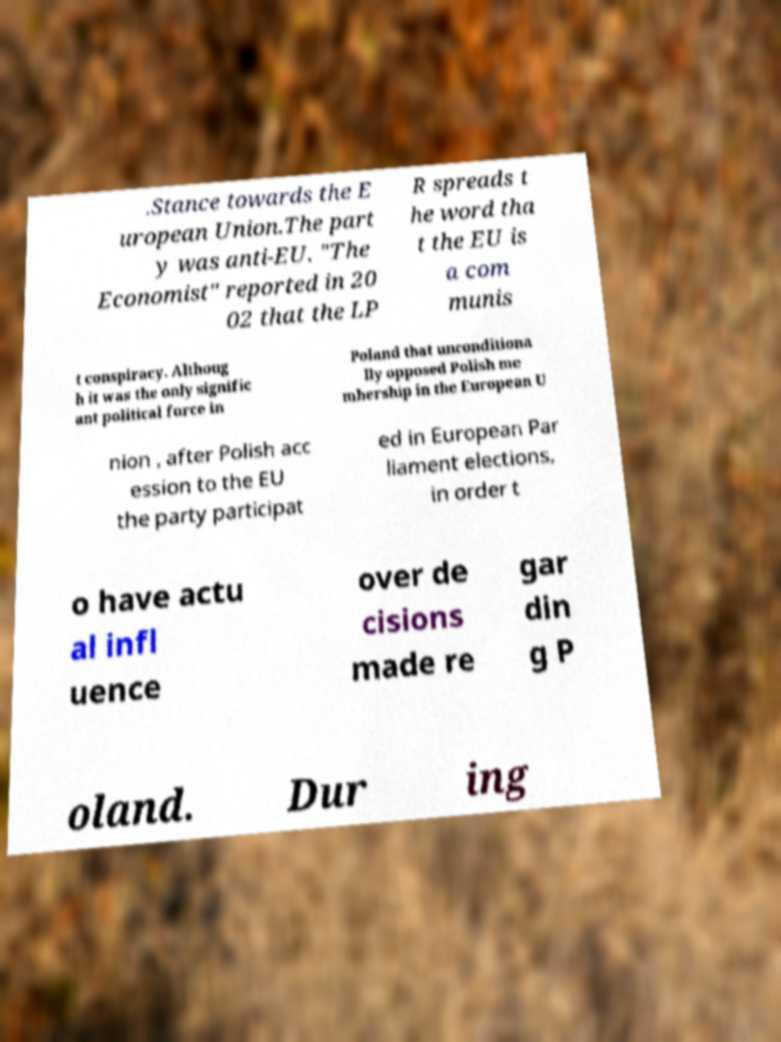Can you accurately transcribe the text from the provided image for me? .Stance towards the E uropean Union.The part y was anti-EU. "The Economist" reported in 20 02 that the LP R spreads t he word tha t the EU is a com munis t conspiracy. Althoug h it was the only signific ant political force in Poland that unconditiona lly opposed Polish me mbership in the European U nion , after Polish acc ession to the EU the party participat ed in European Par liament elections, in order t o have actu al infl uence over de cisions made re gar din g P oland. Dur ing 